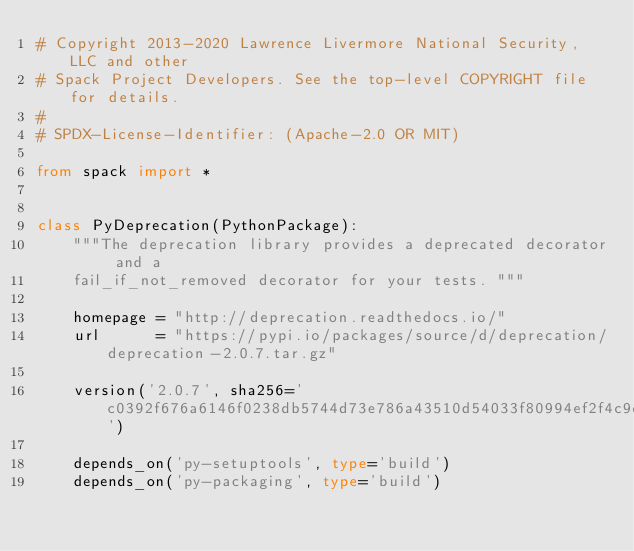Convert code to text. <code><loc_0><loc_0><loc_500><loc_500><_Python_># Copyright 2013-2020 Lawrence Livermore National Security, LLC and other
# Spack Project Developers. See the top-level COPYRIGHT file for details.
#
# SPDX-License-Identifier: (Apache-2.0 OR MIT)

from spack import *


class PyDeprecation(PythonPackage):
    """The deprecation library provides a deprecated decorator and a
    fail_if_not_removed decorator for your tests. """

    homepage = "http://deprecation.readthedocs.io/"
    url      = "https://pypi.io/packages/source/d/deprecation/deprecation-2.0.7.tar.gz"

    version('2.0.7', sha256='c0392f676a6146f0238db5744d73e786a43510d54033f80994ef2f4c9df192ed')

    depends_on('py-setuptools', type='build')
    depends_on('py-packaging', type='build')
</code> 